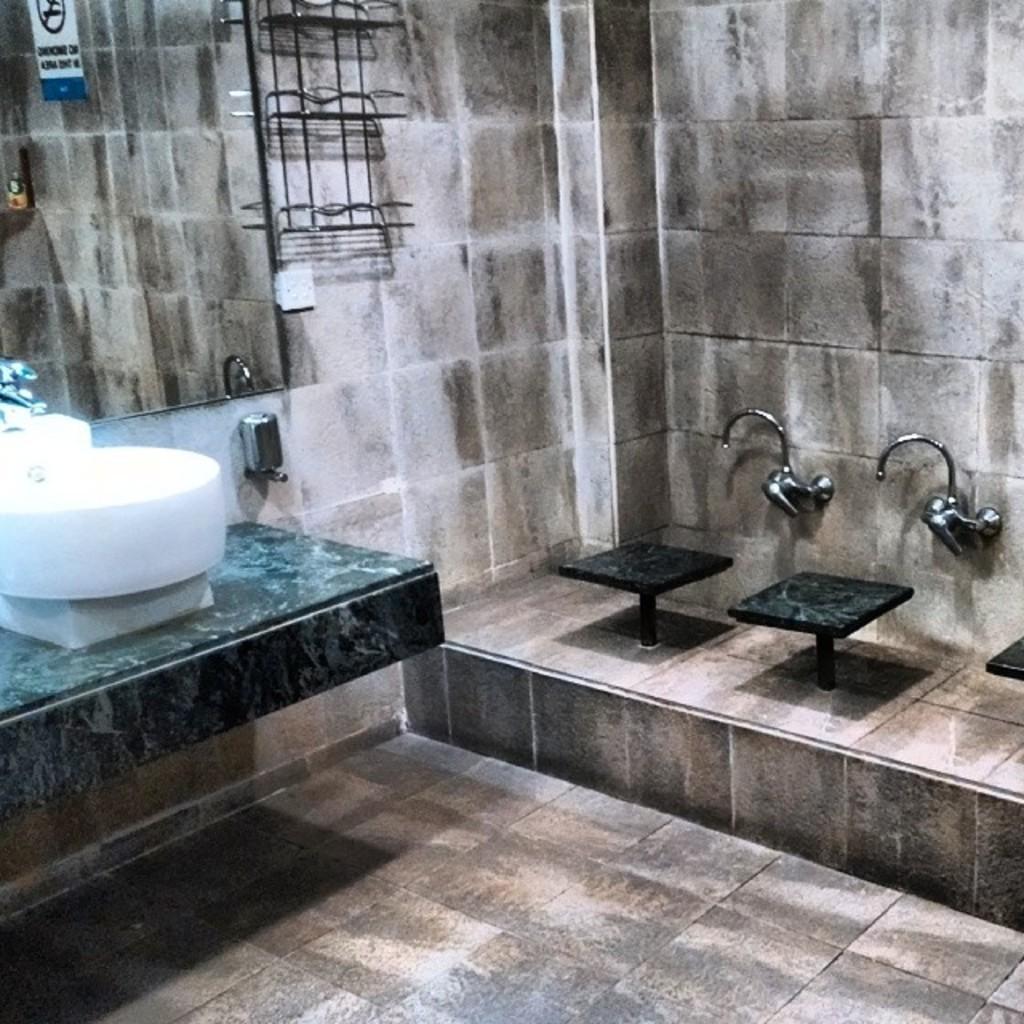How would you summarize this image in a sentence or two? It is a picture inside of a restroom. In this image there is a mirror, stools, taps, sink, sticker and objects. Mirror is on the wall. 